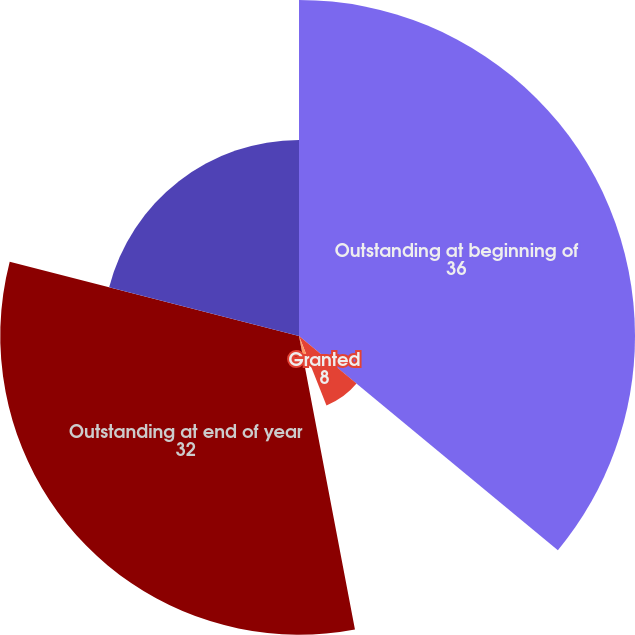Convert chart. <chart><loc_0><loc_0><loc_500><loc_500><pie_chart><fcel>Outstanding at beginning of<fcel>Granted<fcel>Exercised<fcel>Outstanding at end of year<fcel>Exercisable at end of year<nl><fcel>36.0%<fcel>8.0%<fcel>3.0%<fcel>32.0%<fcel>21.0%<nl></chart> 